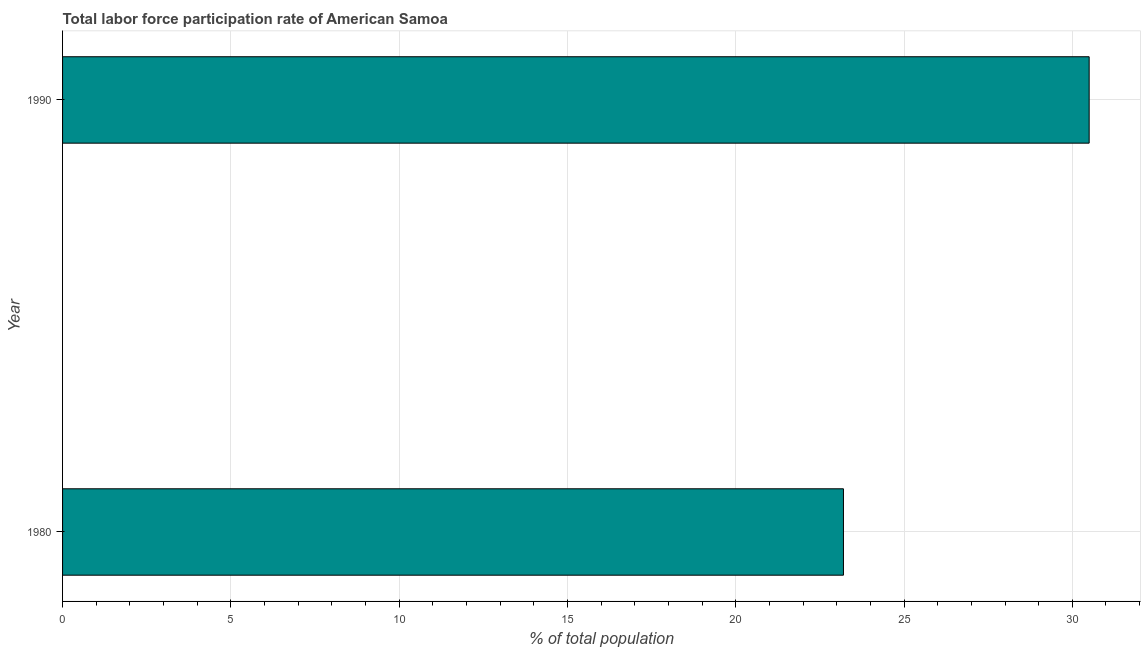Does the graph contain any zero values?
Your answer should be very brief. No. What is the title of the graph?
Give a very brief answer. Total labor force participation rate of American Samoa. What is the label or title of the X-axis?
Offer a terse response. % of total population. What is the total labor force participation rate in 1980?
Ensure brevity in your answer.  23.2. Across all years, what is the maximum total labor force participation rate?
Keep it short and to the point. 30.5. Across all years, what is the minimum total labor force participation rate?
Keep it short and to the point. 23.2. In which year was the total labor force participation rate minimum?
Your answer should be compact. 1980. What is the sum of the total labor force participation rate?
Ensure brevity in your answer.  53.7. What is the average total labor force participation rate per year?
Make the answer very short. 26.85. What is the median total labor force participation rate?
Give a very brief answer. 26.85. What is the ratio of the total labor force participation rate in 1980 to that in 1990?
Provide a succinct answer. 0.76. How many years are there in the graph?
Your response must be concise. 2. What is the difference between two consecutive major ticks on the X-axis?
Your response must be concise. 5. Are the values on the major ticks of X-axis written in scientific E-notation?
Your answer should be compact. No. What is the % of total population of 1980?
Offer a very short reply. 23.2. What is the % of total population of 1990?
Keep it short and to the point. 30.5. What is the ratio of the % of total population in 1980 to that in 1990?
Keep it short and to the point. 0.76. 